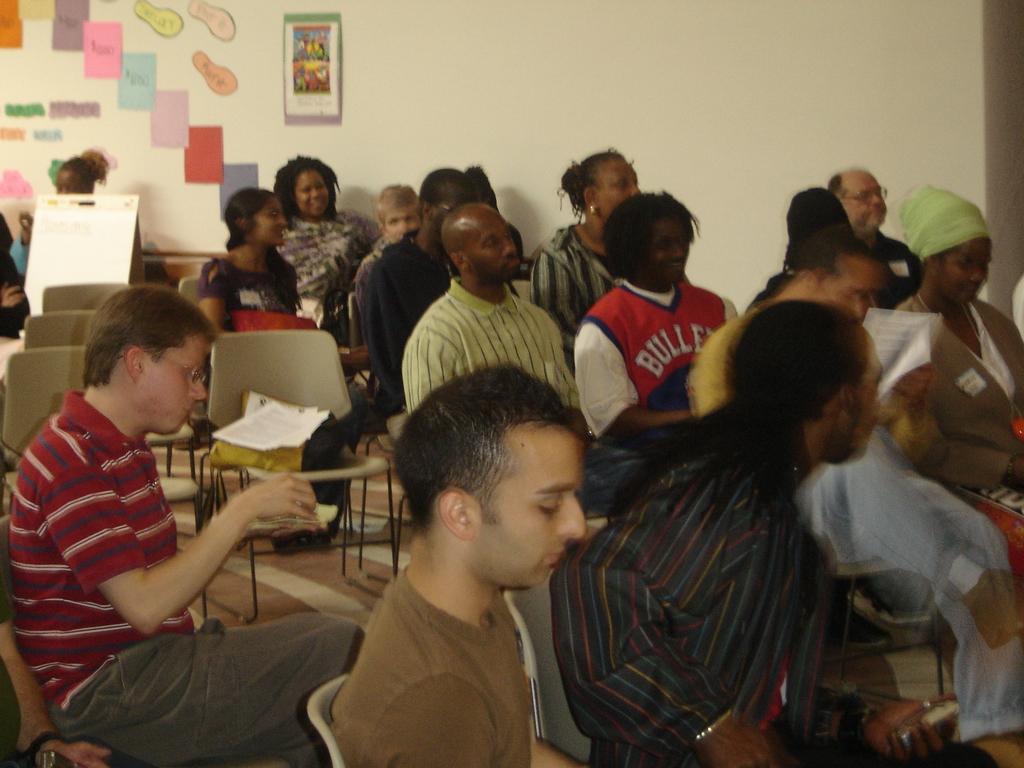Can you describe this image briefly? In this image I can see a group of people are sitting on the chairs and few are holding books in their hand. In the background I can see a wall, wall paintings, photo frame and so on. This image is taken may be in a hall. 